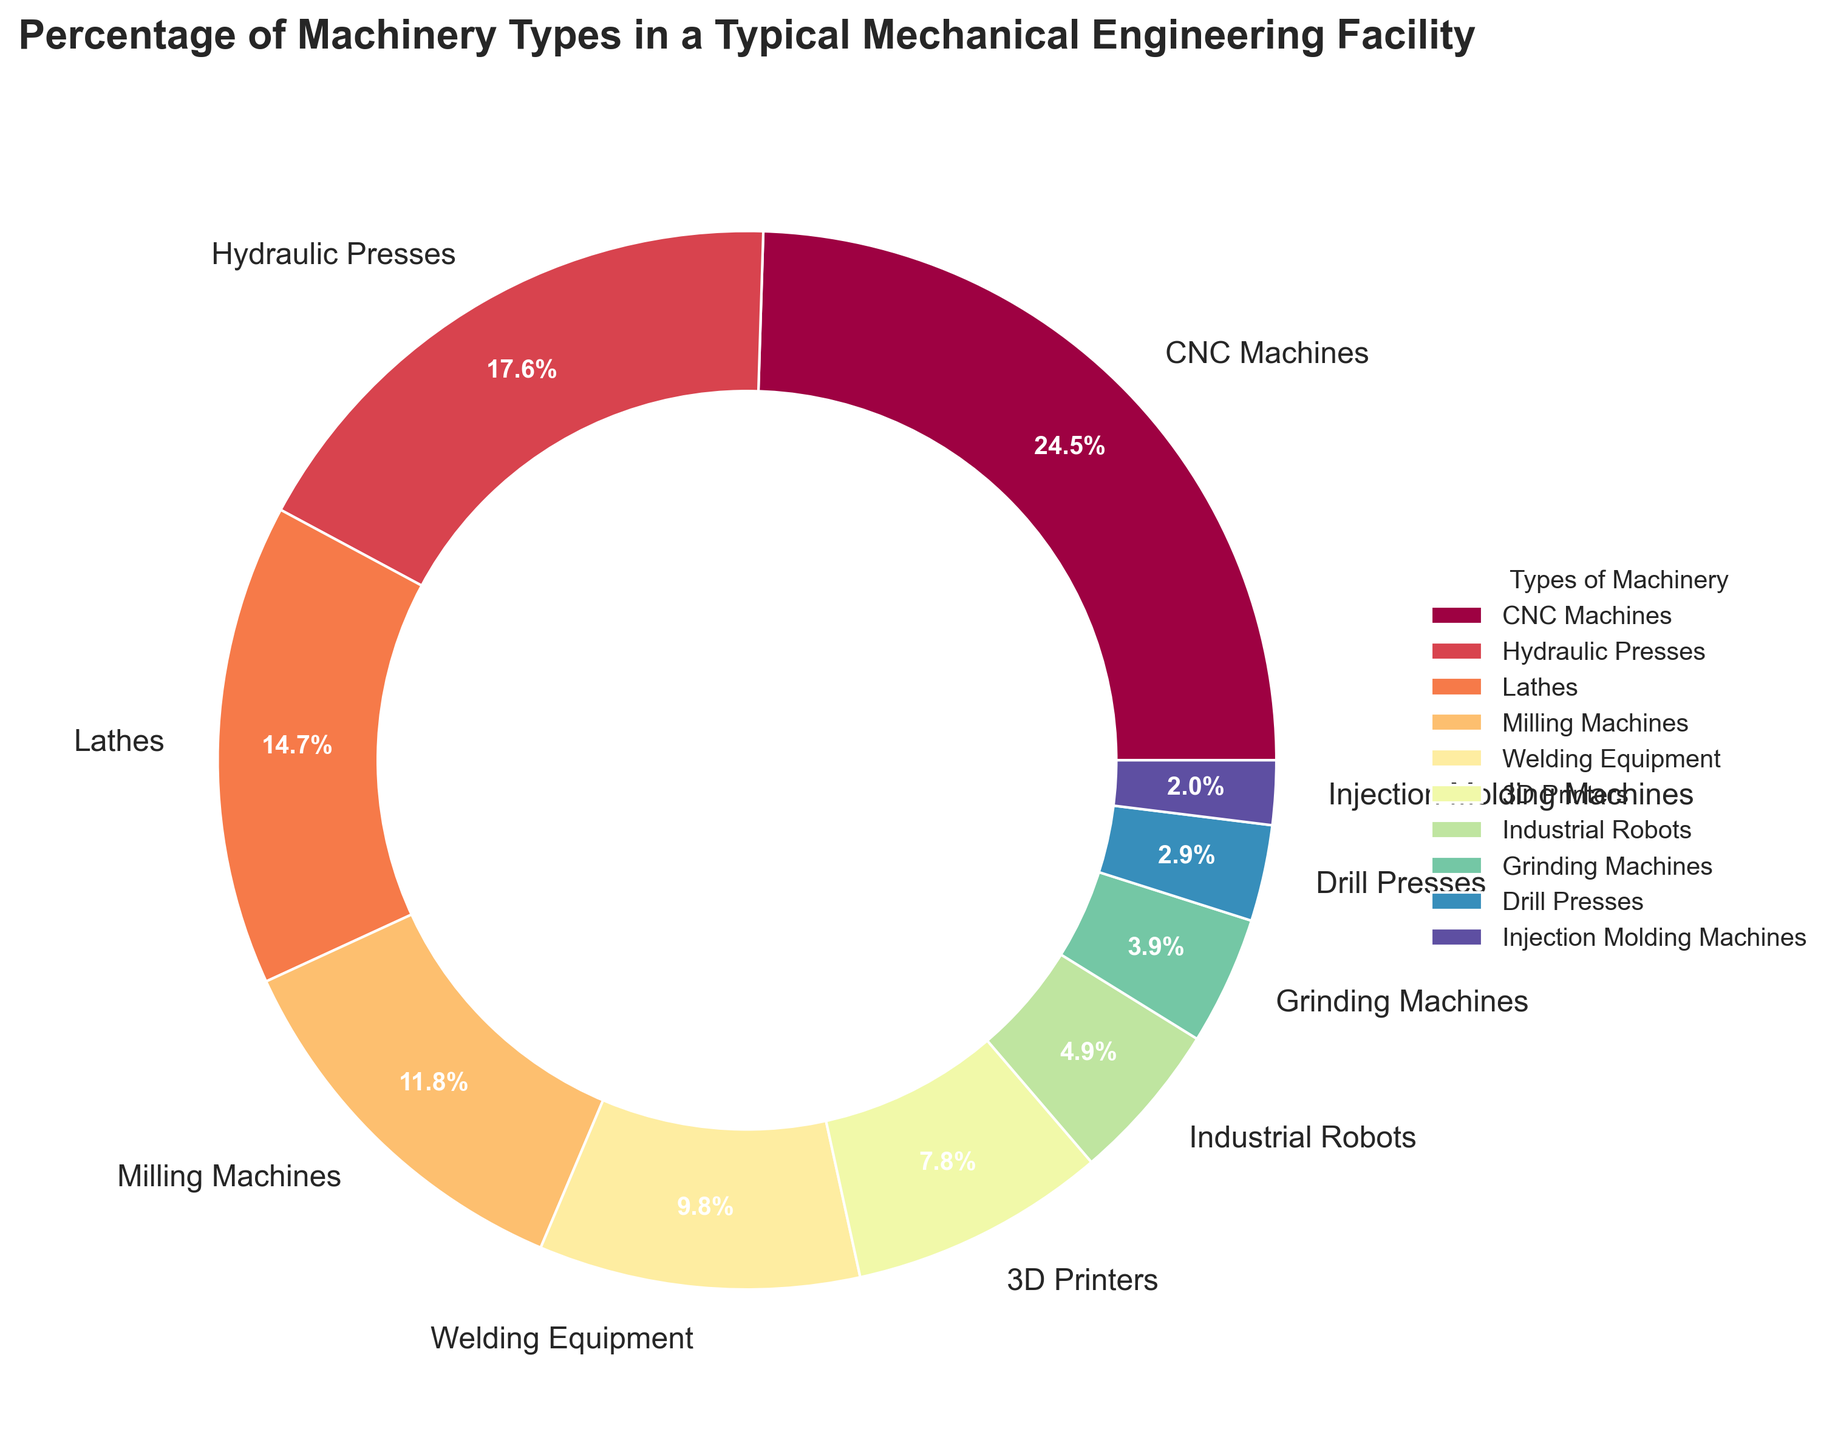What's the sum of the percentages of CNC Machines and Hydraulic Presses? From the pie chart, the percentage for CNC Machines is 25% and for Hydraulic Presses is 18%. Adding them together, 25% + 18% = 43%.
Answer: 43% Which type of machinery has the smallest percentage? In the pie chart, Injection Molding Machines have the smallest percentage at 2%.
Answer: Injection Molding Machines Is the percentage of 3D Printers greater than the percentage of Drill Presses? From the pie chart, the percentage of 3D Printers is 8%, while the percentage of Drill Presses is 3%. Since 8% is greater than 3%, the answer is yes.
Answer: Yes How many machinery types are represented in the pie chart? To determine the number of machinery types, count the distinct slices in the pie chart. There are 10 types: CNC Machines, Hydraulic Presses, Lathes, Milling Machines, Welding Equipment, 3D Printers, Industrial Robots, Grinding Machines, Drill Presses, and Injection Molding Machines.
Answer: 10 What is the difference between the percentage of Lathes and Welding Equipment? The percentage of Lathes is 15% and the percentage of Welding Equipment is 10%. Subtracting them, 15% - 10% = 5%.
Answer: 5% Which machinery type has a purple wedge in the pie chart? The wedge for Injection Molding Machines is colored purple in the pie chart.
Answer: Injection Molding Machines What is the combined percentage of all types of machinery except CNC Machines and Industrial Robots? Excluding CNC Machines (25%) and Industrial Robots (5%), sum the rest: 18% (Hydraulic Presses) + 15% (Lathes) + 12% (Milling Machines) + 10% (Welding Equipment) + 8% (3D Printers) + 4% (Grinding Machines) + 3% (Drill Presses) + 2% (Injection Molding Machines) = 72%.
Answer: 72% What percentage of machinery types have percentages greater than or equal to 10%? The types with percentages greater than or equal to 10% are CNC Machines (25%), Hydraulic Presses (18%), Lathes (15%), Milling Machines (12%), and Welding Equipment (10%). There are 5 types, and their total percentage is 25% + 18% + 15% + 12% + 10% = 80%.
Answer: 80% Which machinery type's wedge is the second largest? By comparing the sizes of the wedges in the pie chart, Hydraulic Presses have the second largest wedge, representing 18%.
Answer: Hydraulic Presses 